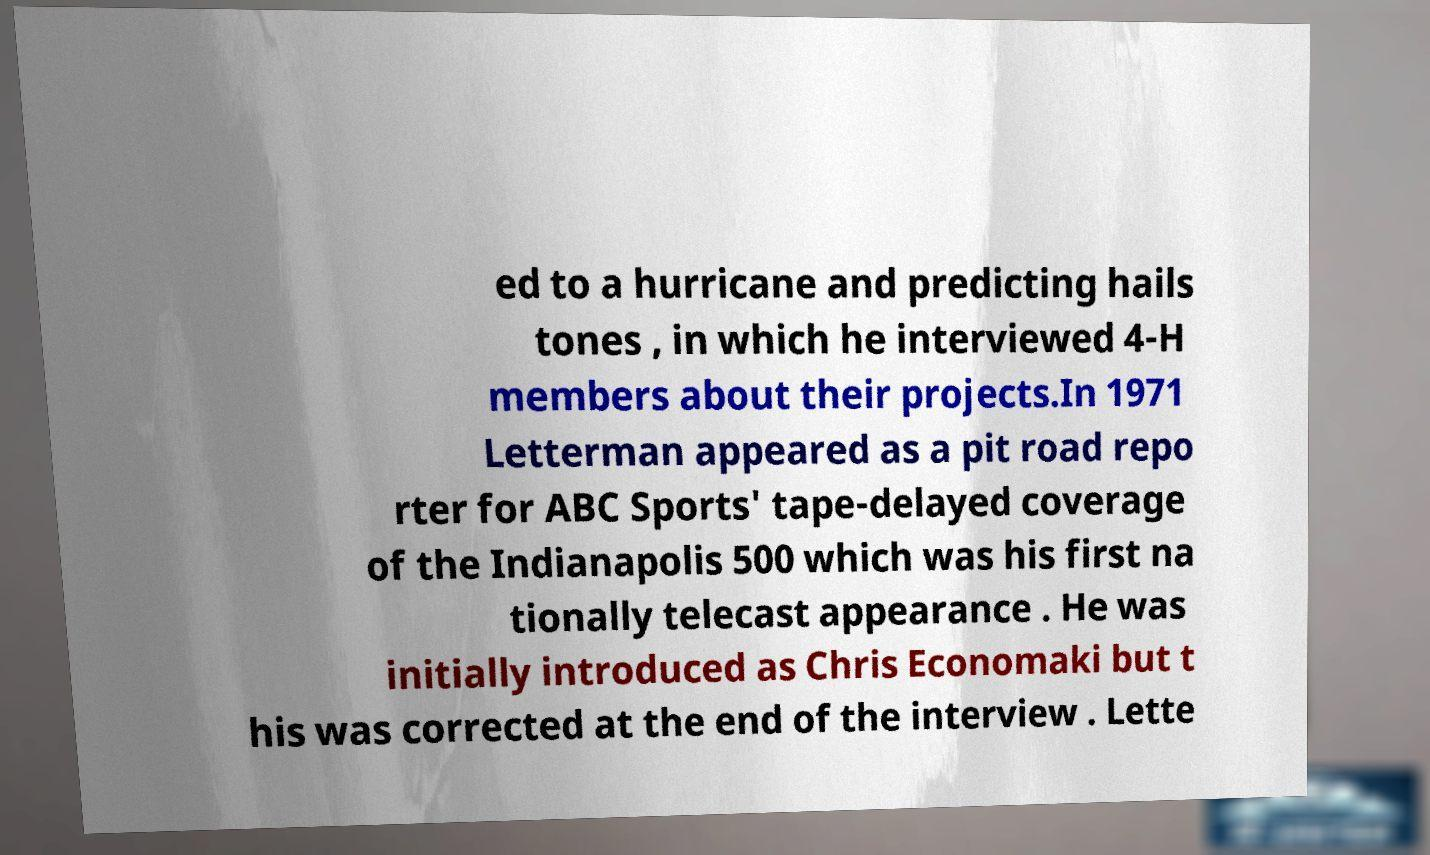Could you extract and type out the text from this image? ed to a hurricane and predicting hails tones , in which he interviewed 4-H members about their projects.In 1971 Letterman appeared as a pit road repo rter for ABC Sports' tape-delayed coverage of the Indianapolis 500 which was his first na tionally telecast appearance . He was initially introduced as Chris Economaki but t his was corrected at the end of the interview . Lette 